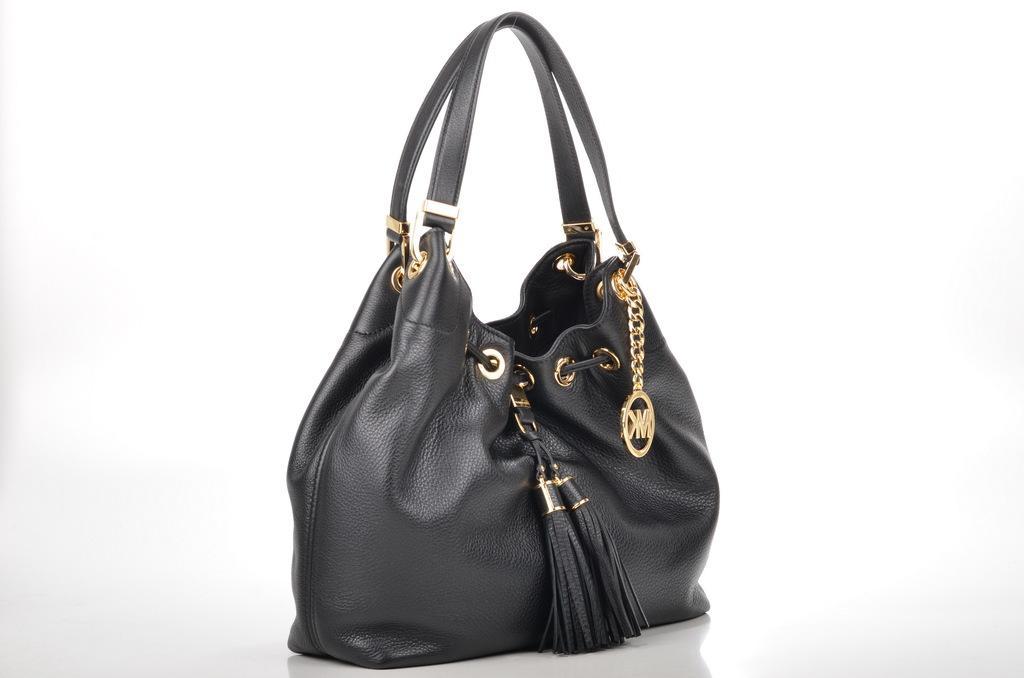Could you give a brief overview of what you see in this image? This is the black colored leather bag. 